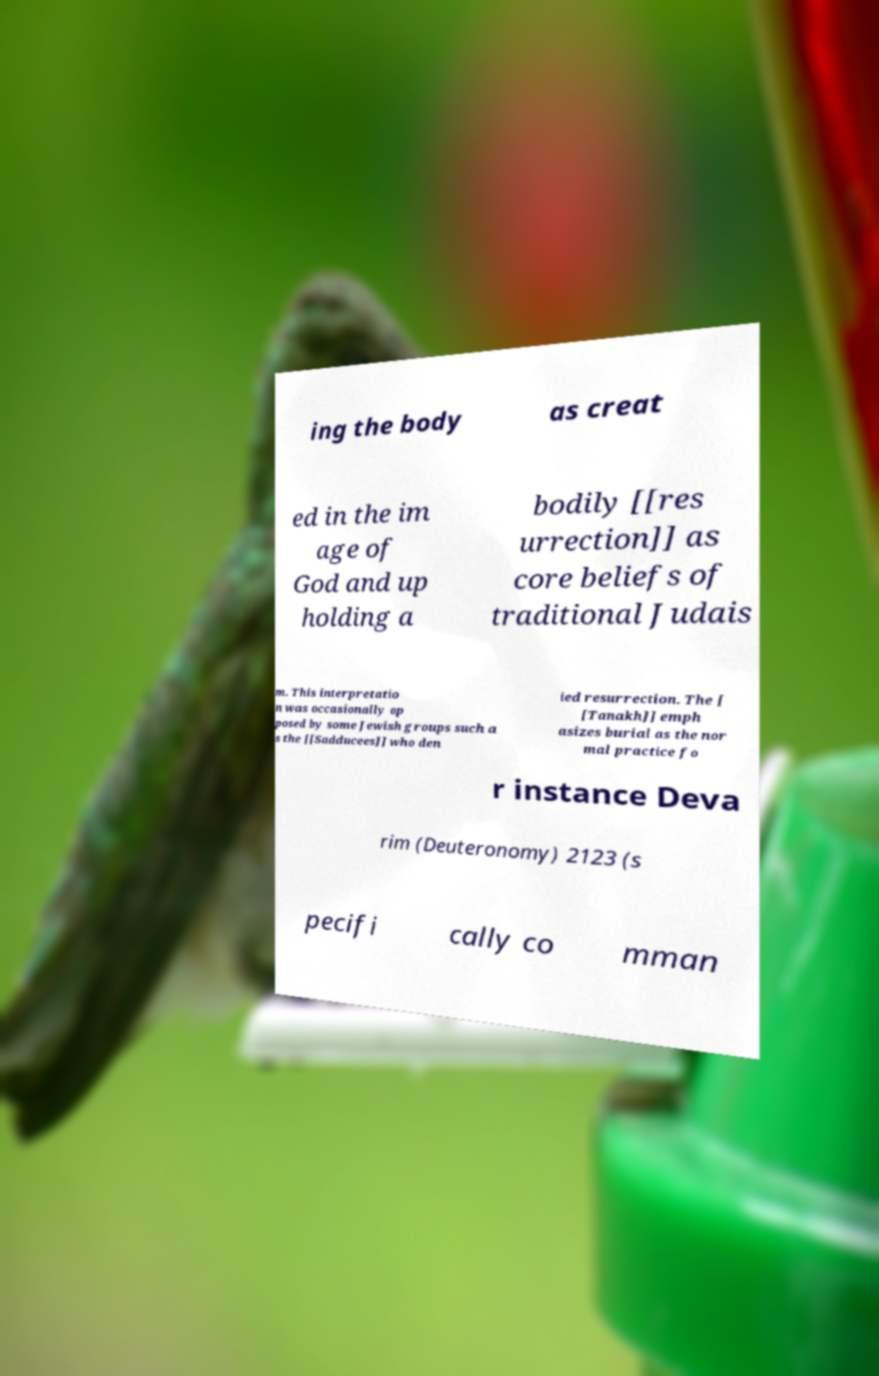What messages or text are displayed in this image? I need them in a readable, typed format. ing the body as creat ed in the im age of God and up holding a bodily [[res urrection]] as core beliefs of traditional Judais m. This interpretatio n was occasionally op posed by some Jewish groups such a s the [[Sadducees]] who den ied resurrection. The [ [Tanakh]] emph asizes burial as the nor mal practice fo r instance Deva rim (Deuteronomy) 2123 (s pecifi cally co mman 